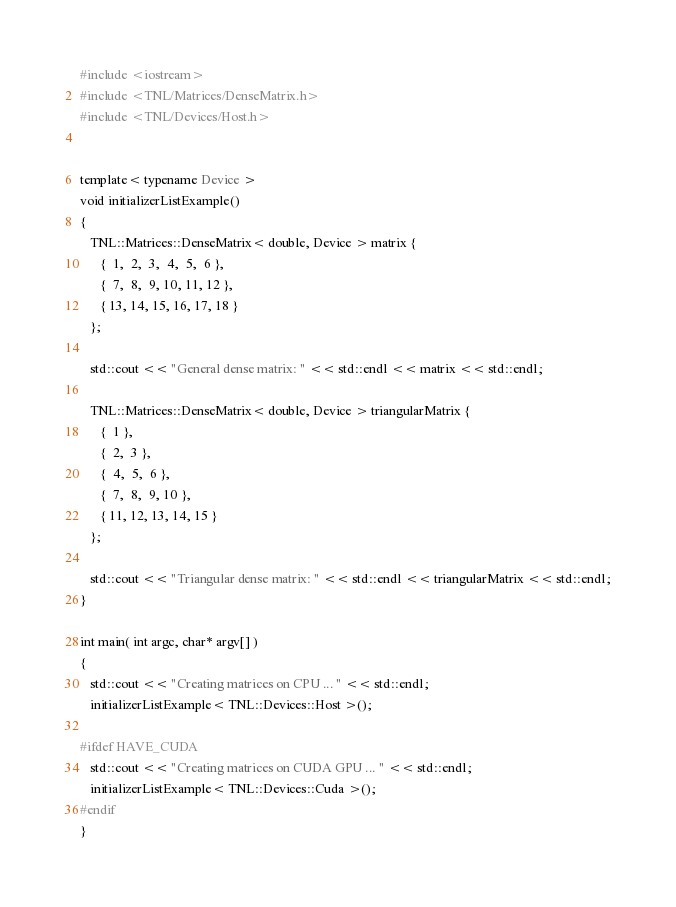Convert code to text. <code><loc_0><loc_0><loc_500><loc_500><_C++_>#include <iostream>
#include <TNL/Matrices/DenseMatrix.h>
#include <TNL/Devices/Host.h>


template< typename Device >
void initializerListExample()
{
   TNL::Matrices::DenseMatrix< double, Device > matrix {
      {  1,  2,  3,  4,  5,  6 },
      {  7,  8,  9, 10, 11, 12 },
      { 13, 14, 15, 16, 17, 18 }
   };

   std::cout << "General dense matrix: " << std::endl << matrix << std::endl;

   TNL::Matrices::DenseMatrix< double, Device > triangularMatrix {
      {  1 },
      {  2,  3 },
      {  4,  5,  6 },
      {  7,  8,  9, 10 },
      { 11, 12, 13, 14, 15 }
   };

   std::cout << "Triangular dense matrix: " << std::endl << triangularMatrix << std::endl;
}

int main( int argc, char* argv[] )
{
   std::cout << "Creating matrices on CPU ... " << std::endl;
   initializerListExample< TNL::Devices::Host >();

#ifdef HAVE_CUDA
   std::cout << "Creating matrices on CUDA GPU ... " << std::endl;
   initializerListExample< TNL::Devices::Cuda >();
#endif
}
</code> 